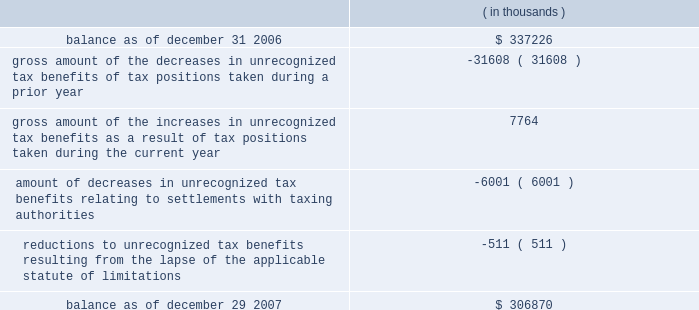The changes in the gross amount of unrecognized tax benefits for the year ended december 29 , 2007 are as follows: .
As of december 29 , 2007 , $ 228.4 million of unrecognized tax benefits would , if recognized , reduce the effective tax rate , as compared to $ 232.1 million as of december 31 , 2006 , the first day of cadence 2019s fiscal year .
The total amounts of interest and penalties recognized in the consolidated income statement for the year ended december 29 , 2007 resulted in net tax benefits of $ 11.1 million and $ 0.4 million , respectively , primarily due to the effective settlement of tax audits during the year .
The total amounts of gross accrued interest and penalties recognized in the consolidated balance sheets as of december 29 , 2007 , were $ 47.9 million and $ 9.7 million , respectively as compared to $ 65.8 million and $ 10.1 million , respectively as of december 31 , 2006 .
Note 9 .
Acquisitions for each of the acquisitions described below , the results of operations and the estimated fair value of the assets acquired and liabilities assumed have been included in cadence 2019s consolidated financial statements from the date of the acquisition .
Comparative pro forma financial information for all 2007 , 2006 and 2005 acquisitions have not been presented because the results of operations were not material to cadence 2019s consolidated financial statements .
2007 acquisitions during 2007 , cadence acquired invarium , inc. , a san jose-based developer of advanced lithography-modeling and pattern-synthesis technology , and clear shape technologies , inc. , a san jose-based design for manufacturing technology company specializing in design-side solutions to minimize yield loss for advanced semiconductor integrated circuits .
Cadence acquired these two companies for an aggregate purchase price of $ 75.5 million , which included the payment of cash , the fair value of assumed options and acquisition costs .
The $ 45.7 million of goodwill recorded in connection with these acquisitions is not expected to be deductible for income tax purposes .
Prior to acquiring clear shape technologies , inc. , cadence had an investment of $ 2.0 million in the company , representing a 12% ( 12 % ) ownership interest , which had been accounted for under the cost method of accounting .
In accordance with sfas no .
141 , 201cbusiness combinations , 201d cadence accounted for this acquisition as a step acquisition .
Subsequent adjustments to the purchase price of these acquired companies are included in the 201cother 201d line of the changes of goodwill table in note 10 below .
2006 acquisition in march 2006 , cadence acquired a company for an aggregate initial purchase price of $ 25.8 million , which included the payment of cash , the fair value of assumed options and acquisition costs .
The preliminary allocation of the purchase price was recorded as $ 17.4 million of goodwill , $ 9.4 million of identifiable intangible assets and $ ( 1.0 ) million of net liabilities .
The $ 17.4 million of goodwill recorded in connection with this acquisition is not expected to be deductible for income tax purposes .
Subsequent adjustments to the purchase price of this acquired company are included in the 201cother 201d line of the changes of goodwill table in note 10 below. .
What percentage of the aggregate purchase price for the two companies in 2007 is goodwill? 
Computations: (45.7 / 75.5)
Answer: 0.6053. 